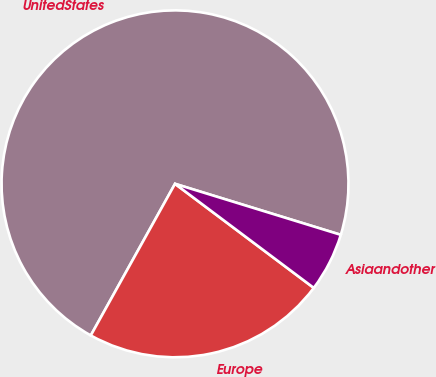<chart> <loc_0><loc_0><loc_500><loc_500><pie_chart><fcel>UnitedStates<fcel>Europe<fcel>Asiaandother<nl><fcel>71.68%<fcel>22.83%<fcel>5.49%<nl></chart> 